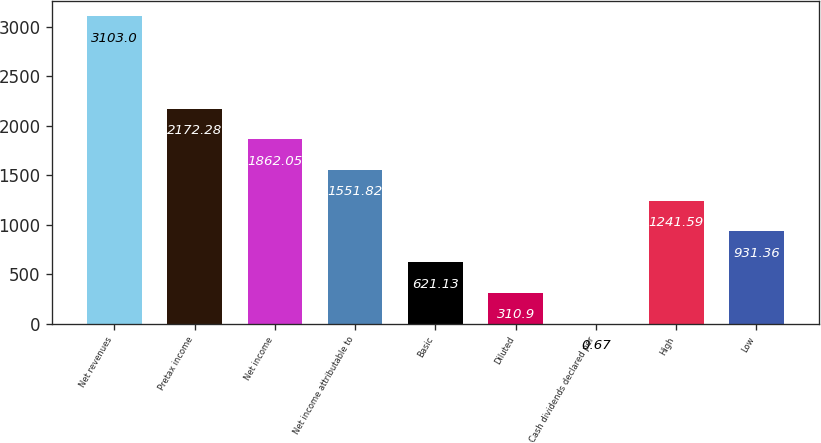Convert chart. <chart><loc_0><loc_0><loc_500><loc_500><bar_chart><fcel>Net revenues<fcel>Pretax income<fcel>Net income<fcel>Net income attributable to<fcel>Basic<fcel>Diluted<fcel>Cash dividends declared per<fcel>High<fcel>Low<nl><fcel>3103<fcel>2172.28<fcel>1862.05<fcel>1551.82<fcel>621.13<fcel>310.9<fcel>0.67<fcel>1241.59<fcel>931.36<nl></chart> 